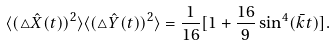<formula> <loc_0><loc_0><loc_500><loc_500>\langle ( \triangle \hat { X } ( t ) ) ^ { 2 } \rangle \langle ( \triangle \hat { Y } ( t ) ) ^ { 2 } \rangle = \frac { 1 } { 1 6 } [ 1 + \frac { 1 6 } { 9 } \sin ^ { 4 } ( \bar { k } t ) ] .</formula> 